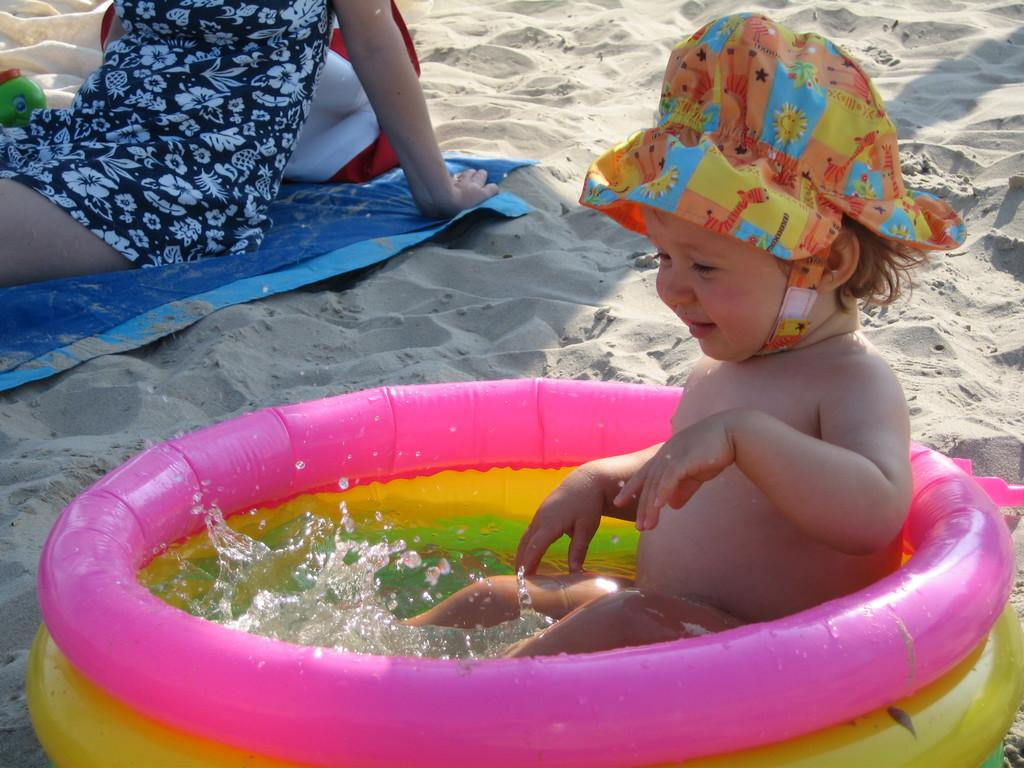How many people are in the image? There are two persons in the image. What are the positions of the two people in the image? One person is sitting in a tub, and the other person is sitting on a mat. What other objects or items can be seen in the image? There is a toy and sand visible in the image. What type of property is visible in the image? There is no property visible in the image; it features two people, a toy, and sand. What color is the mist in the image? There is no mist present in the image. 